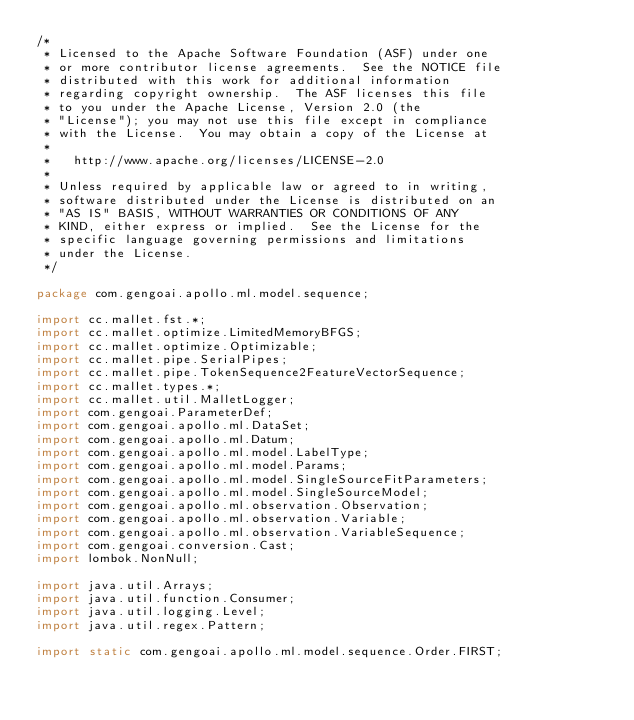Convert code to text. <code><loc_0><loc_0><loc_500><loc_500><_Java_>/*
 * Licensed to the Apache Software Foundation (ASF) under one
 * or more contributor license agreements.  See the NOTICE file
 * distributed with this work for additional information
 * regarding copyright ownership.  The ASF licenses this file
 * to you under the Apache License, Version 2.0 (the
 * "License"); you may not use this file except in compliance
 * with the License.  You may obtain a copy of the License at
 *
 *   http://www.apache.org/licenses/LICENSE-2.0
 *
 * Unless required by applicable law or agreed to in writing,
 * software distributed under the License is distributed on an
 * "AS IS" BASIS, WITHOUT WARRANTIES OR CONDITIONS OF ANY
 * KIND, either express or implied.  See the License for the
 * specific language governing permissions and limitations
 * under the License.
 */

package com.gengoai.apollo.ml.model.sequence;

import cc.mallet.fst.*;
import cc.mallet.optimize.LimitedMemoryBFGS;
import cc.mallet.optimize.Optimizable;
import cc.mallet.pipe.SerialPipes;
import cc.mallet.pipe.TokenSequence2FeatureVectorSequence;
import cc.mallet.types.*;
import cc.mallet.util.MalletLogger;
import com.gengoai.ParameterDef;
import com.gengoai.apollo.ml.DataSet;
import com.gengoai.apollo.ml.Datum;
import com.gengoai.apollo.ml.model.LabelType;
import com.gengoai.apollo.ml.model.Params;
import com.gengoai.apollo.ml.model.SingleSourceFitParameters;
import com.gengoai.apollo.ml.model.SingleSourceModel;
import com.gengoai.apollo.ml.observation.Observation;
import com.gengoai.apollo.ml.observation.Variable;
import com.gengoai.apollo.ml.observation.VariableSequence;
import com.gengoai.conversion.Cast;
import lombok.NonNull;

import java.util.Arrays;
import java.util.function.Consumer;
import java.util.logging.Level;
import java.util.regex.Pattern;

import static com.gengoai.apollo.ml.model.sequence.Order.FIRST;</code> 